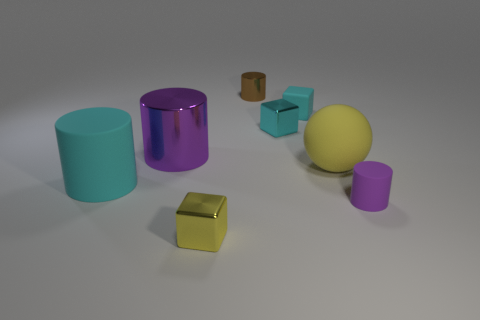Add 2 small brown shiny cylinders. How many objects exist? 10 Subtract all cubes. How many objects are left? 5 Add 5 brown shiny things. How many brown shiny things exist? 6 Subtract 0 red spheres. How many objects are left? 8 Subtract all small brown cylinders. Subtract all cyan shiny cubes. How many objects are left? 6 Add 5 small cubes. How many small cubes are left? 8 